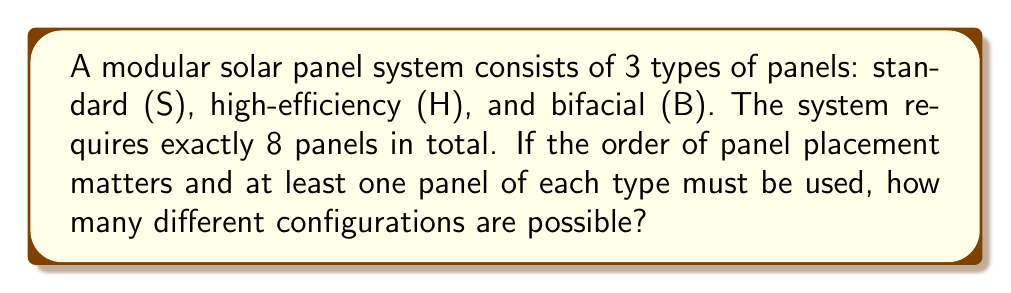What is the answer to this math problem? Let's approach this step-by-step:

1) First, we need to ensure at least one panel of each type is used. So we start with S, H, and B.

2) We now have 5 remaining spots to fill with any combination of the three types.

3) This is a permutation with repetition problem. We can use the multiplication principle.

4) For each of the 5 remaining spots, we have 3 choices (S, H, or B).

5) Therefore, the number of ways to fill these 5 spots is $3^5$.

6) However, we're not done yet. Remember, the order of all 8 panels matters.

7) So, we need to consider all the ways to arrange these 8 panels (the 3 fixed ones and the 5 variable ones).

8) This is a straightforward permutation of 8 elements, which is 8!.

9) Combining steps 5 and 8, our final calculation is:

   $$ 3^5 \cdot 8! $$

10) Let's compute this:
    $3^5 = 243$
    $8! = 40,320$
    $243 \cdot 40,320 = 9,797,760$

Therefore, there are 9,797,760 possible configurations.
Answer: $9,797,760$ 